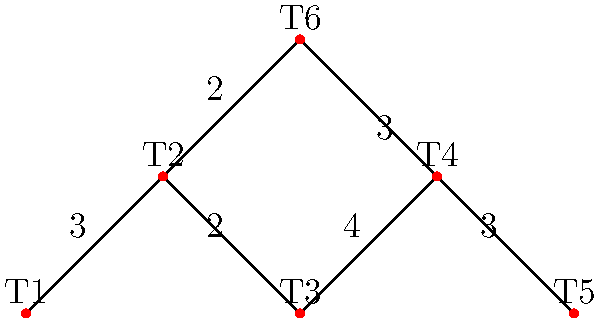In this playful network of a lynx's territory, each node (T1 to T6) represents a favorite hiding spot, and the edges show the paths between them with their distances in kilometers. What's the minimum distance a curious lynx needs to travel to visit all hiding spots, starting and ending at T1? Let's approach this step-by-step:

1) First, we need to find a path that visits all nodes and returns to T1. This is known as the Traveling Salesman Problem.

2) We'll use a simple method to solve this: try all possible routes and find the shortest one.

3) The possible routes are:
   T1 - T2 - T3 - T4 - T5 - T4 - T6 - T2 - T1
   T1 - T2 - T6 - T4 - T5 - T4 - T3 - T2 - T1
   T1 - T2 - T6 - T4 - T3 - T4 - T5 - T4 - T2 - T1

4) Let's calculate the distance for each route:
   Route 1: 3 + 2 + 4 + 3 + 4 + 3 + 2 + 3 = 24 km
   Route 2: 3 + 2 + 3 + 3 + 4 + 4 + 2 + 3 = 24 km
   Route 3: 3 + 2 + 3 + 4 + 4 + 3 + 4 + 2 + 3 = 28 km

5) The minimum distance is 24 km, which can be achieved by two different routes.

Therefore, the mischievous lynx needs to travel a minimum of 24 km to visit all hiding spots and return to the starting point.
Answer: 24 km 